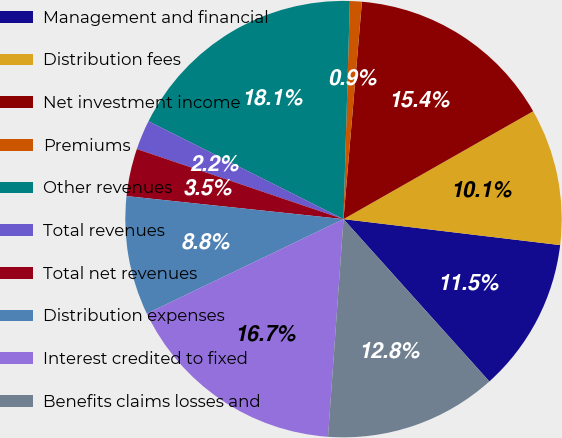Convert chart to OTSL. <chart><loc_0><loc_0><loc_500><loc_500><pie_chart><fcel>Management and financial<fcel>Distribution fees<fcel>Net investment income<fcel>Premiums<fcel>Other revenues<fcel>Total revenues<fcel>Total net revenues<fcel>Distribution expenses<fcel>Interest credited to fixed<fcel>Benefits claims losses and<nl><fcel>11.45%<fcel>10.13%<fcel>15.42%<fcel>0.88%<fcel>18.06%<fcel>2.2%<fcel>3.52%<fcel>8.81%<fcel>16.74%<fcel>12.78%<nl></chart> 